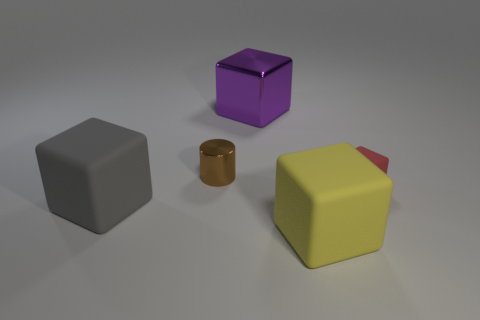Subtract all small red rubber blocks. How many blocks are left? 3 Subtract all cylinders. How many objects are left? 4 Subtract all yellow cubes. How many cubes are left? 3 Add 2 small things. How many objects exist? 7 Subtract 3 blocks. How many blocks are left? 1 Add 4 red matte objects. How many red matte objects are left? 5 Add 1 big cyan metal cubes. How many big cyan metal cubes exist? 1 Subtract 0 yellow cylinders. How many objects are left? 5 Subtract all green cylinders. Subtract all green blocks. How many cylinders are left? 1 Subtract all green cubes. How many gray cylinders are left? 0 